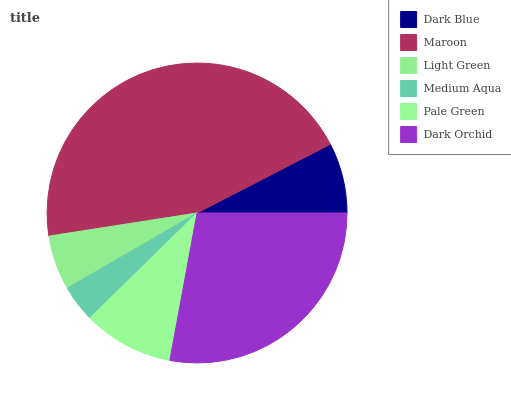Is Medium Aqua the minimum?
Answer yes or no. Yes. Is Maroon the maximum?
Answer yes or no. Yes. Is Light Green the minimum?
Answer yes or no. No. Is Light Green the maximum?
Answer yes or no. No. Is Maroon greater than Light Green?
Answer yes or no. Yes. Is Light Green less than Maroon?
Answer yes or no. Yes. Is Light Green greater than Maroon?
Answer yes or no. No. Is Maroon less than Light Green?
Answer yes or no. No. Is Pale Green the high median?
Answer yes or no. Yes. Is Dark Blue the low median?
Answer yes or no. Yes. Is Medium Aqua the high median?
Answer yes or no. No. Is Dark Orchid the low median?
Answer yes or no. No. 